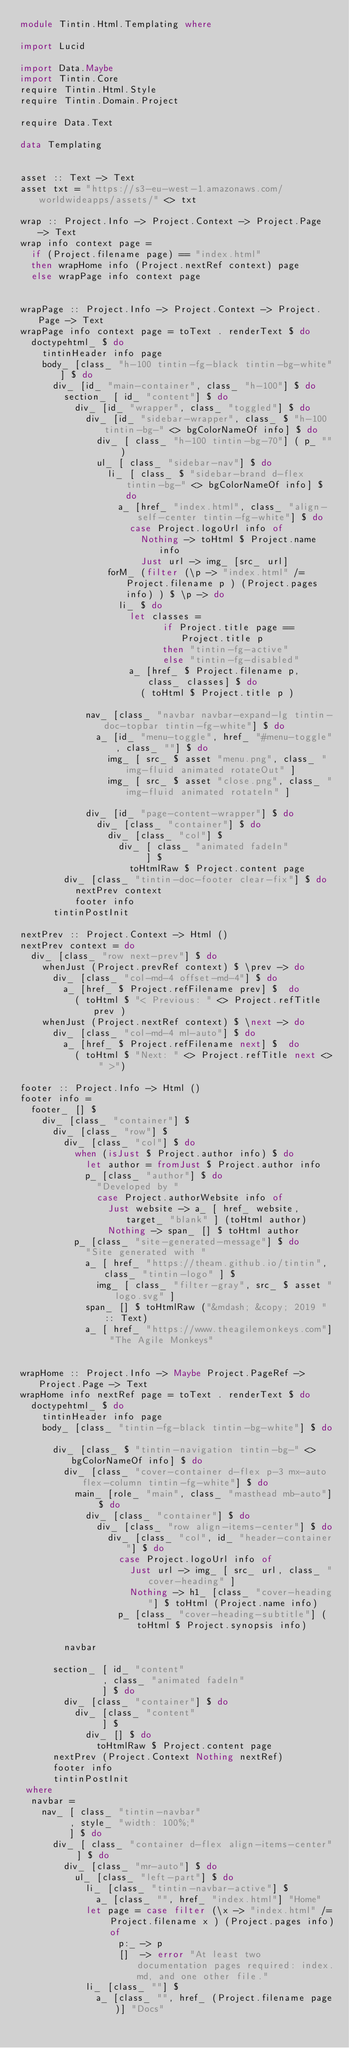Convert code to text. <code><loc_0><loc_0><loc_500><loc_500><_Haskell_>module Tintin.Html.Templating where

import Lucid

import Data.Maybe
import Tintin.Core
require Tintin.Html.Style
require Tintin.Domain.Project

require Data.Text

data Templating


asset :: Text -> Text
asset txt = "https://s3-eu-west-1.amazonaws.com/worldwideapps/assets/" <> txt

wrap :: Project.Info -> Project.Context -> Project.Page -> Text
wrap info context page =
  if (Project.filename page) == "index.html"
  then wrapHome info (Project.nextRef context) page
  else wrapPage info context page


wrapPage :: Project.Info -> Project.Context -> Project.Page -> Text
wrapPage info context page = toText . renderText $ do
  doctypehtml_ $ do
    tintinHeader info page
    body_ [class_ "h-100 tintin-fg-black tintin-bg-white"] $ do
      div_ [id_ "main-container", class_ "h-100"] $ do
        section_ [ id_ "content"] $ do
          div_ [id_ "wrapper", class_ "toggled"] $ do
            div_ [id_ "sidebar-wrapper", class_ $ "h-100 tintin-bg-" <> bgColorNameOf info] $ do
              div_ [ class_ "h-100 tintin-bg-70"] ( p_ "" )
              ul_ [ class_ "sidebar-nav"] $ do
                li_ [ class_ $ "sidebar-brand d-flex tintin-bg-" <> bgColorNameOf info] $ do
                  a_ [href_ "index.html", class_ "align-self-center tintin-fg-white"] $ do
                    case Project.logoUrl info of
                      Nothing -> toHtml $ Project.name info
                      Just url -> img_ [src_ url]
                forM_ (filter (\p -> "index.html" /= Project.filename p ) (Project.pages info) ) $ \p -> do
                  li_ $ do
                    let classes =
                          if Project.title page == Project.title p
                          then "tintin-fg-active"
                          else "tintin-fg-disabled"
                    a_ [href_ $ Project.filename p, class_ classes] $ do
                      ( toHtml $ Project.title p )

            nav_ [class_ "navbar navbar-expand-lg tintin-doc-topbar tintin-fg-white"] $ do
              a_ [id_ "menu-toggle", href_ "#menu-toggle", class_ ""] $ do
                img_ [ src_ $ asset "menu.png", class_ "img-fluid animated rotateOut" ]
                img_ [ src_ $ asset "close.png", class_ "img-fluid animated rotateIn" ]

            div_ [id_ "page-content-wrapper"] $ do
              div_ [class_ "container"] $ do
                div_ [class_ "col"] $
                  div_ [ class_ "animated fadeIn"
                       ] $
                    toHtmlRaw $ Project.content page
        div_ [class_ "tintin-doc-footer clear-fix"] $ do
          nextPrev context
          footer info
      tintinPostInit

nextPrev :: Project.Context -> Html ()
nextPrev context = do
  div_ [class_ "row next-prev"] $ do
    whenJust (Project.prevRef context) $ \prev -> do
      div_ [class_ "col-md-4 offset-md-4"] $ do
        a_ [href_ $ Project.refFilename prev] $  do
          ( toHtml $ "< Previous: " <> Project.refTitle prev )
    whenJust (Project.nextRef context) $ \next -> do
      div_ [class_ "col-md-4 ml-auto"] $ do
        a_ [href_ $ Project.refFilename next] $  do
          ( toHtml $ "Next: " <> Project.refTitle next <> " >")

footer :: Project.Info -> Html ()
footer info =
  footer_ [] $
    div_ [class_ "container"] $
      div_ [class_ "row"] $ 
        div_ [class_ "col"] $ do
          when (isJust $ Project.author info) $ do
            let author = fromJust $ Project.author info
            p_ [class_ "author"] $ do
              "Developed by "
              case Project.authorWebsite info of
                Just website -> a_ [ href_ website, target_ "blank" ] (toHtml author)
                Nothing -> span_ [] $ toHtml author 
          p_ [class_ "site-generated-message"] $ do
            "Site generated with "
            a_ [ href_ "https://theam.github.io/tintin", class_ "tintin-logo" ] $
              img_ [ class_ "filter-gray", src_ $ asset "logo.svg" ]
            span_ [] $ toHtmlRaw ("&mdash; &copy; 2019 " :: Text)
            a_ [ href_ "https://www.theagilemonkeys.com"] "The Agile Monkeys"


wrapHome :: Project.Info -> Maybe Project.PageRef -> Project.Page -> Text
wrapHome info nextRef page = toText . renderText $ do
  doctypehtml_ $ do
    tintinHeader info page
    body_ [class_ "tintin-fg-black tintin-bg-white"] $ do

      div_ [class_ $ "tintin-navigation tintin-bg-" <> bgColorNameOf info] $ do
        div_ [class_ "cover-container d-flex p-3 mx-auto flex-column tintin-fg-white"] $ do
          main_ [role_ "main", class_ "masthead mb-auto"] $ do
            div_ [class_ "container"] $ do
              div_ [class_ "row align-items-center"] $ do
                div_ [class_ "col", id_ "header-container"] $ do
                  case Project.logoUrl info of
                    Just url -> img_ [ src_ url, class_ "cover-heading" ]
                    Nothing -> h1_ [class_ "cover-heading"] $ toHtml (Project.name info)
                  p_ [class_ "cover-heading-subtitle"] (toHtml $ Project.synopsis info)

        navbar

      section_ [ id_ "content"
               , class_ "animated fadeIn"
               ] $ do
        div_ [class_ "container"] $ do
          div_ [class_ "content"
               ] $
            div_ [] $ do
              toHtmlRaw $ Project.content page
      nextPrev (Project.Context Nothing nextRef)
      footer info
      tintinPostInit
 where
  navbar =
    nav_ [ class_ "tintin-navbar"
         , style_ "width: 100%;"
         ] $ do
      div_ [ class_ "container d-flex align-items-center" ] $ do
        div_ [class_ "mr-auto"] $ do
          ul_ [class_ "left-part"] $ do
            li_ [class_ "tintin-navbar-active"] $
              a_ [class_ "", href_ "index.html"] "Home"
            let page = case filter (\x -> "index.html" /= Project.filename x ) (Project.pages info) of
                  p:_ -> p
                  []  -> error "At least two documentation pages required: index.md, and one other file."
            li_ [class_ ""] $
              a_ [class_ "", href_ (Project.filename page)] "Docs"</code> 